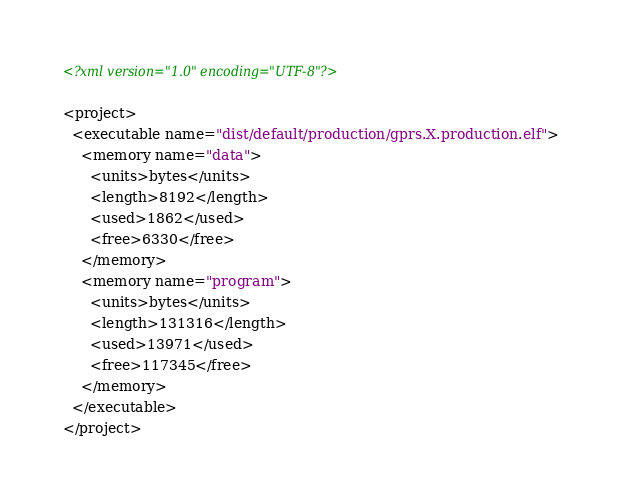Convert code to text. <code><loc_0><loc_0><loc_500><loc_500><_XML_><?xml version="1.0" encoding="UTF-8"?>

<project>
  <executable name="dist/default/production/gprs.X.production.elf">
    <memory name="data">
      <units>bytes</units>
      <length>8192</length>
      <used>1862</used>
      <free>6330</free>
    </memory>
    <memory name="program">
      <units>bytes</units>
      <length>131316</length>
      <used>13971</used>
      <free>117345</free>
    </memory>
  </executable>
</project>
</code> 